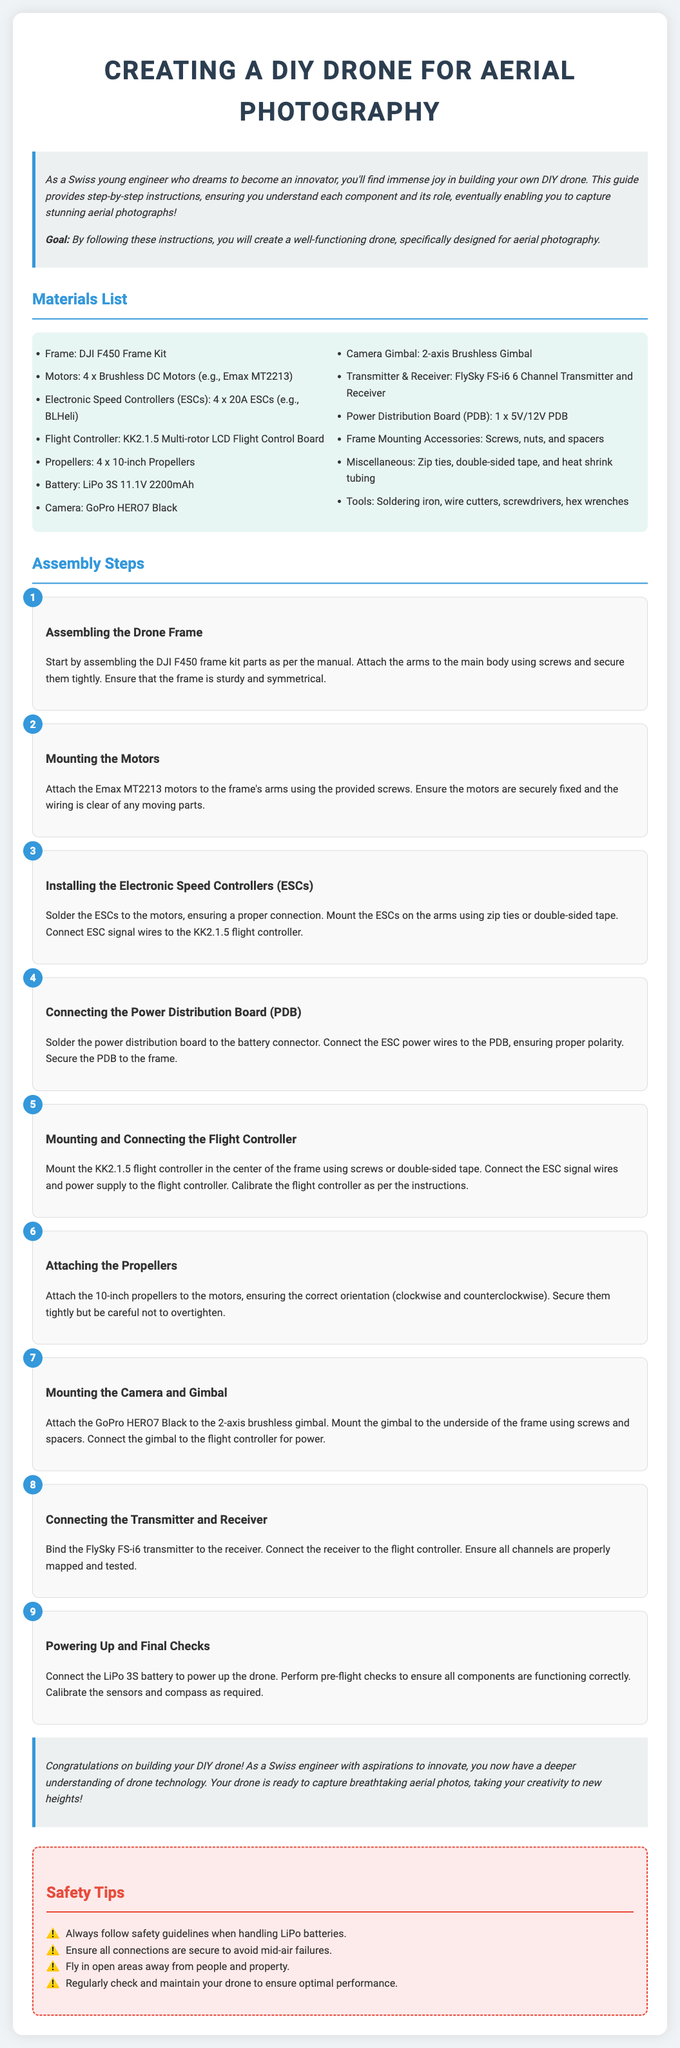What is the first step in the assembly process? The first step is to assemble the DJI F450 frame kit parts as per the manual.
Answer: Assembling the Drone Frame How many motors are required for the drone? The drone requires 4 brushless DC motors.
Answer: 4 What type of battery is specified for the drone? The document specifies a LiPo 3S 11.1V 2200mAh battery.
Answer: LiPo 3S 11.1V 2200mAh Which camera is recommended for aerial photography? The recommended camera is the GoPro HERO7 Black.
Answer: GoPro HERO7 Black What is the role of the Electronic Speed Controllers (ESCs)? The role of ESCs is to control the motor speed and functions.
Answer: Control motor speed What is the purpose of the power distribution board (PDB)? The PDB distributes power to the ESCs and other components.
Answer: Distributes power How should the propellers be oriented when attached to the motors? The propellers should be oriented correctly as clockwise and counterclockwise.
Answer: Clockwise and counterclockwise What should be done before powering up the drone? Pre-flight checks should be performed to ensure all components are functioning correctly.
Answer: Perform pre-flight checks How is the FlySky transmitter connected to the flight controller? The transmitter is bound to the receiver, which is then connected to the flight controller.
Answer: Bound to the receiver 